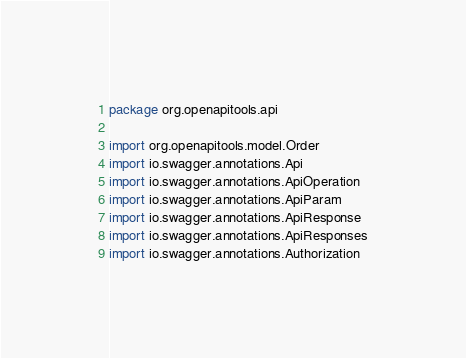Convert code to text. <code><loc_0><loc_0><loc_500><loc_500><_Kotlin_>package org.openapitools.api

import org.openapitools.model.Order
import io.swagger.annotations.Api
import io.swagger.annotations.ApiOperation
import io.swagger.annotations.ApiParam
import io.swagger.annotations.ApiResponse
import io.swagger.annotations.ApiResponses
import io.swagger.annotations.Authorization</code> 